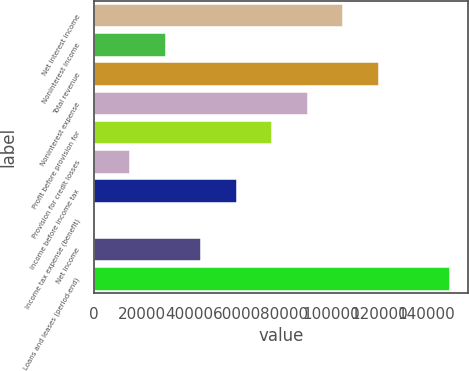<chart> <loc_0><loc_0><loc_500><loc_500><bar_chart><fcel>Net interest income<fcel>Noninterest income<fcel>Total revenue<fcel>Noninterest expense<fcel>Profit before provision for<fcel>Provision for credit losses<fcel>Income before income tax<fcel>Income tax expense (benefit)<fcel>Net income<fcel>Loans and leases (period-end)<nl><fcel>105045<fcel>30198.6<fcel>120014<fcel>90075.8<fcel>75106.5<fcel>15229.3<fcel>60137.2<fcel>260<fcel>45167.9<fcel>149953<nl></chart> 